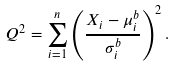Convert formula to latex. <formula><loc_0><loc_0><loc_500><loc_500>Q ^ { 2 } = \sum _ { i = 1 } ^ { n } \left ( \frac { X _ { i } - \mu _ { i } ^ { b } } { \sigma _ { i } ^ { b } } \right ) ^ { 2 } .</formula> 